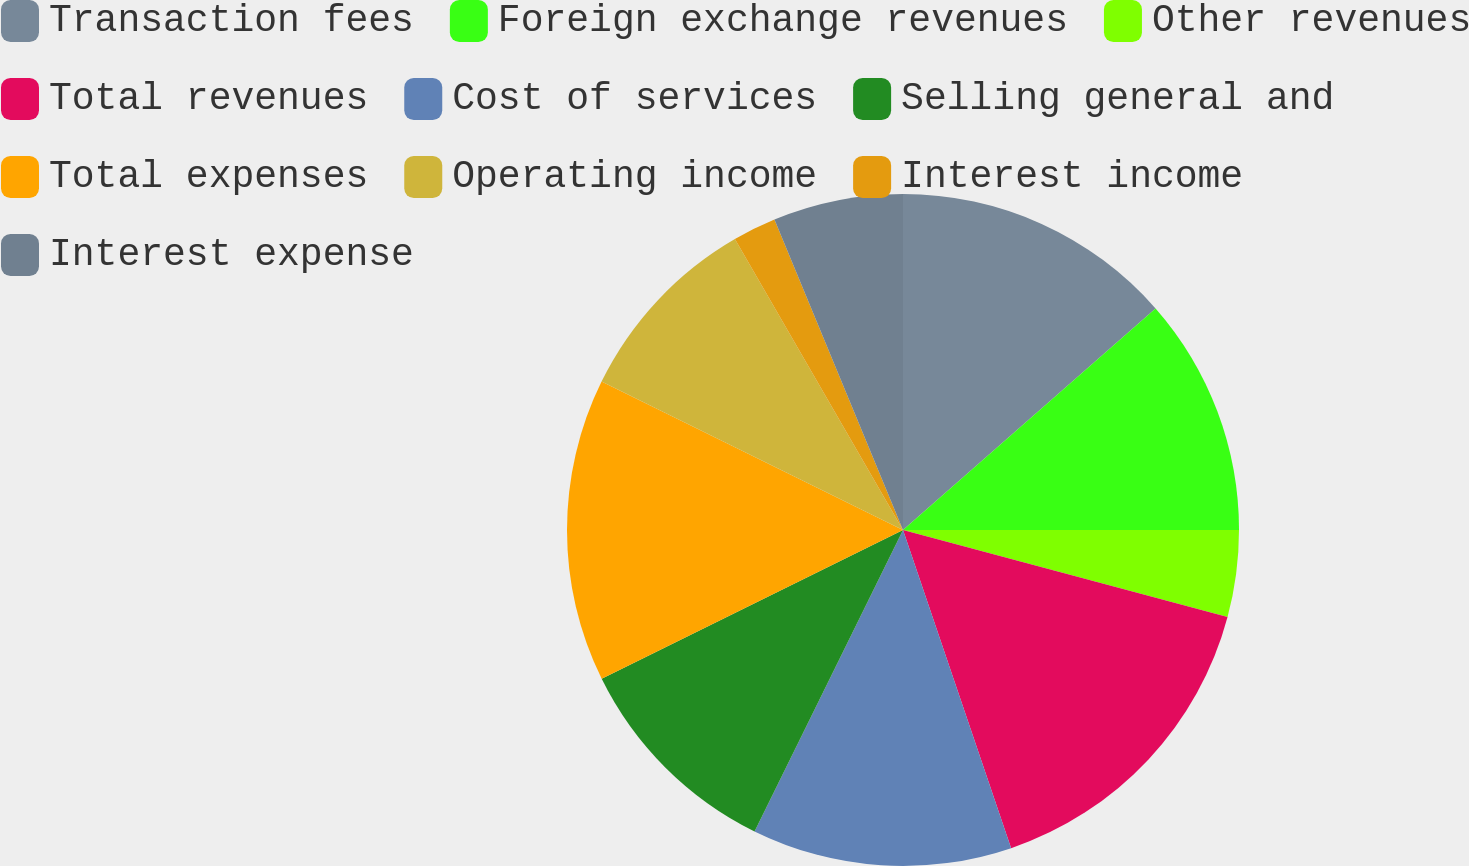Convert chart. <chart><loc_0><loc_0><loc_500><loc_500><pie_chart><fcel>Transaction fees<fcel>Foreign exchange revenues<fcel>Other revenues<fcel>Total revenues<fcel>Cost of services<fcel>Selling general and<fcel>Total expenses<fcel>Operating income<fcel>Interest income<fcel>Interest expense<nl><fcel>13.54%<fcel>11.46%<fcel>4.17%<fcel>15.62%<fcel>12.5%<fcel>10.42%<fcel>14.58%<fcel>9.38%<fcel>2.09%<fcel>6.25%<nl></chart> 